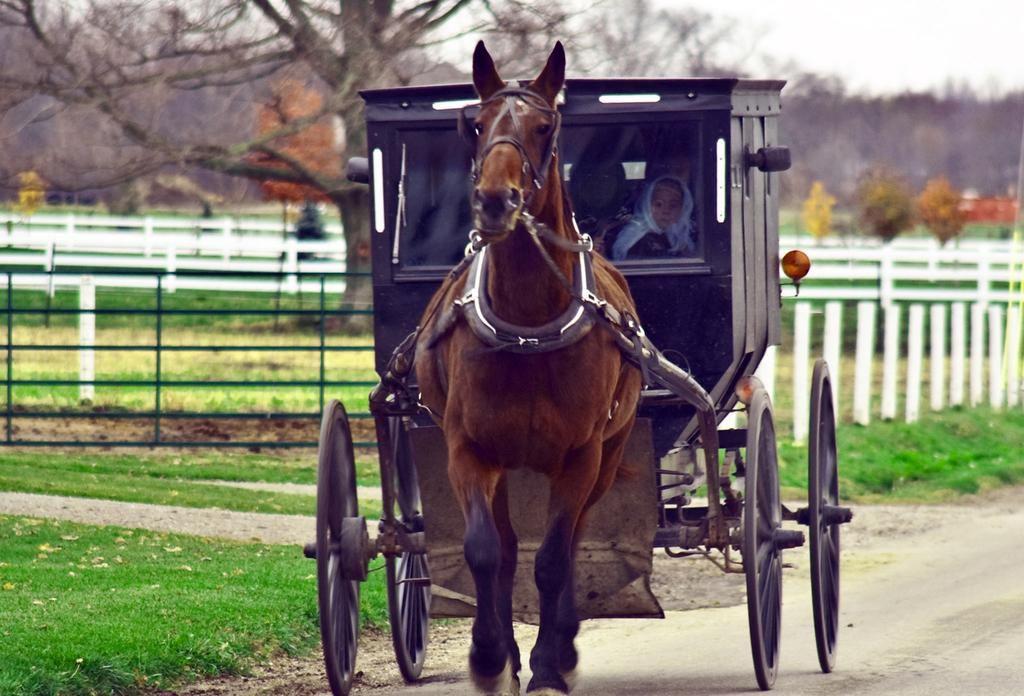What is the main subject in the center of the image? There is a horse cart in the center of the image. Who or what is inside the horse cart? There are people sitting in the horse cart. What can be seen in the background of the image? There is a fence, trees, and the sky visible in the background of the image. What type of ground is visible at the bottom of the image? There is grass at the bottom of the image. What type of sign is hanging from the horse cart in the image? There is no sign hanging from the horse cart in the image. Can you tell me how many servants are attending to the horse cart in the image? There is no mention of servants in the image, as it only shows people sitting in the horse cart. 